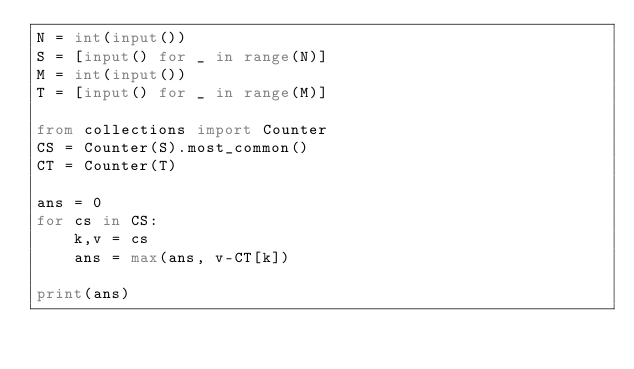<code> <loc_0><loc_0><loc_500><loc_500><_Python_>N = int(input())
S = [input() for _ in range(N)]
M = int(input())
T = [input() for _ in range(M)]

from collections import Counter
CS = Counter(S).most_common()
CT = Counter(T)

ans = 0
for cs in CS:
    k,v = cs
    ans = max(ans, v-CT[k])

print(ans)
</code> 